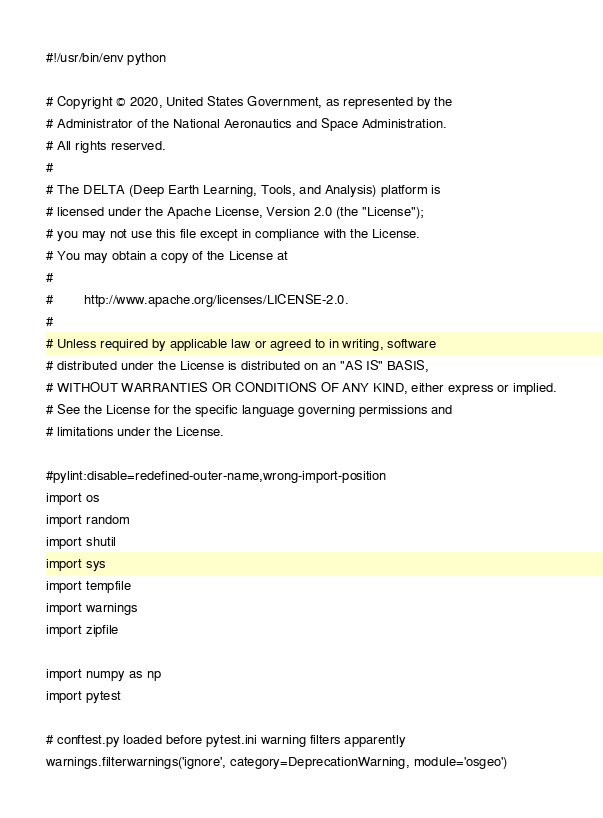<code> <loc_0><loc_0><loc_500><loc_500><_Python_>#!/usr/bin/env python

# Copyright © 2020, United States Government, as represented by the
# Administrator of the National Aeronautics and Space Administration.
# All rights reserved.
#
# The DELTA (Deep Earth Learning, Tools, and Analysis) platform is
# licensed under the Apache License, Version 2.0 (the "License");
# you may not use this file except in compliance with the License.
# You may obtain a copy of the License at
#
#        http://www.apache.org/licenses/LICENSE-2.0.
#
# Unless required by applicable law or agreed to in writing, software
# distributed under the License is distributed on an "AS IS" BASIS,
# WITHOUT WARRANTIES OR CONDITIONS OF ANY KIND, either express or implied.
# See the License for the specific language governing permissions and
# limitations under the License.

#pylint:disable=redefined-outer-name,wrong-import-position
import os
import random
import shutil
import sys
import tempfile
import warnings
import zipfile

import numpy as np
import pytest

# conftest.py loaded before pytest.ini warning filters apparently
warnings.filterwarnings('ignore', category=DeprecationWarning, module='osgeo')
</code> 